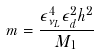Convert formula to latex. <formula><loc_0><loc_0><loc_500><loc_500>m = \frac { \epsilon _ { \nu _ { L } } ^ { 4 } \epsilon _ { d } ^ { 2 } h ^ { 2 } } { M _ { 1 } }</formula> 